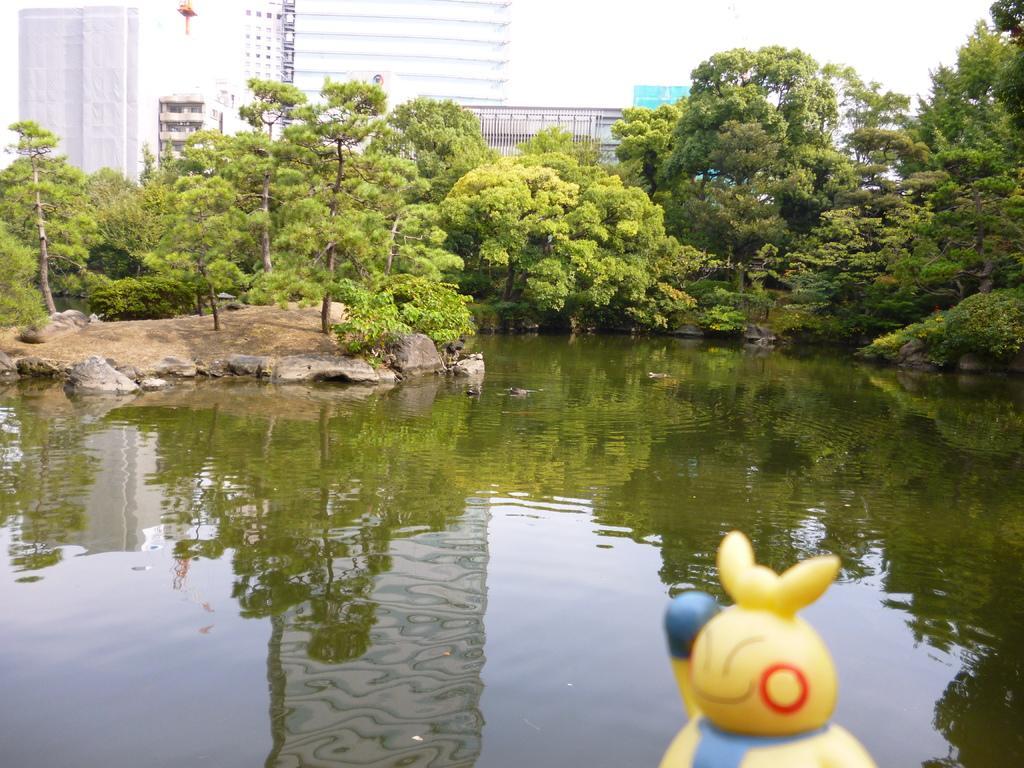How would you summarize this image in a sentence or two? In this image in the front there is a doll. In the center there is water. In the background there are trees, buildings. 